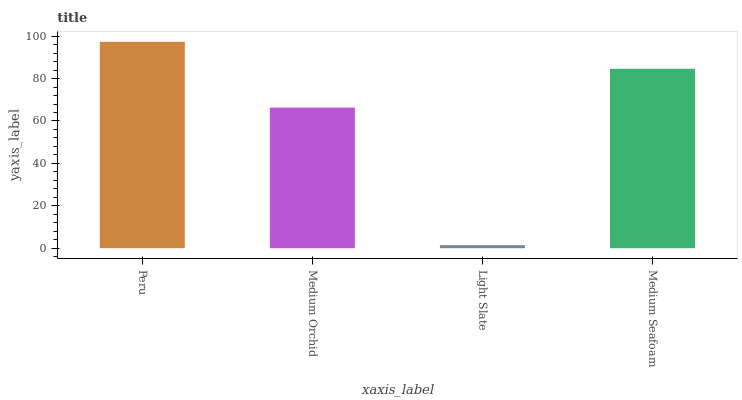Is Medium Orchid the minimum?
Answer yes or no. No. Is Medium Orchid the maximum?
Answer yes or no. No. Is Peru greater than Medium Orchid?
Answer yes or no. Yes. Is Medium Orchid less than Peru?
Answer yes or no. Yes. Is Medium Orchid greater than Peru?
Answer yes or no. No. Is Peru less than Medium Orchid?
Answer yes or no. No. Is Medium Seafoam the high median?
Answer yes or no. Yes. Is Medium Orchid the low median?
Answer yes or no. Yes. Is Peru the high median?
Answer yes or no. No. Is Light Slate the low median?
Answer yes or no. No. 